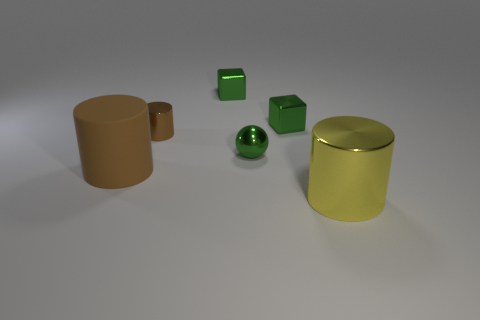Are there any other things that have the same material as the big brown object?
Make the answer very short. No. Is there a tiny metallic object that has the same color as the small metallic ball?
Make the answer very short. Yes. What size is the yellow cylinder that is made of the same material as the sphere?
Give a very brief answer. Large. There is a thing that is the same color as the small cylinder; what is its size?
Your answer should be compact. Large. Is the size of the brown metal cylinder the same as the yellow cylinder?
Your answer should be very brief. No. What color is the big thing to the left of the brown cylinder that is behind the big object behind the big yellow shiny cylinder?
Your answer should be very brief. Brown. Is the shape of the yellow thing the same as the large brown thing?
Make the answer very short. Yes. There is a cylinder that is the same material as the big yellow thing; what color is it?
Offer a terse response. Brown. How many things are either cylinders behind the large yellow object or big cylinders?
Provide a short and direct response. 3. How big is the brown cylinder that is right of the large brown matte object?
Your answer should be very brief. Small. 